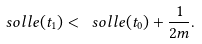<formula> <loc_0><loc_0><loc_500><loc_500>\ s o l l e ( t _ { 1 } ) < \ s o l l e ( t _ { 0 } ) + \frac { 1 } { 2 m } .</formula> 